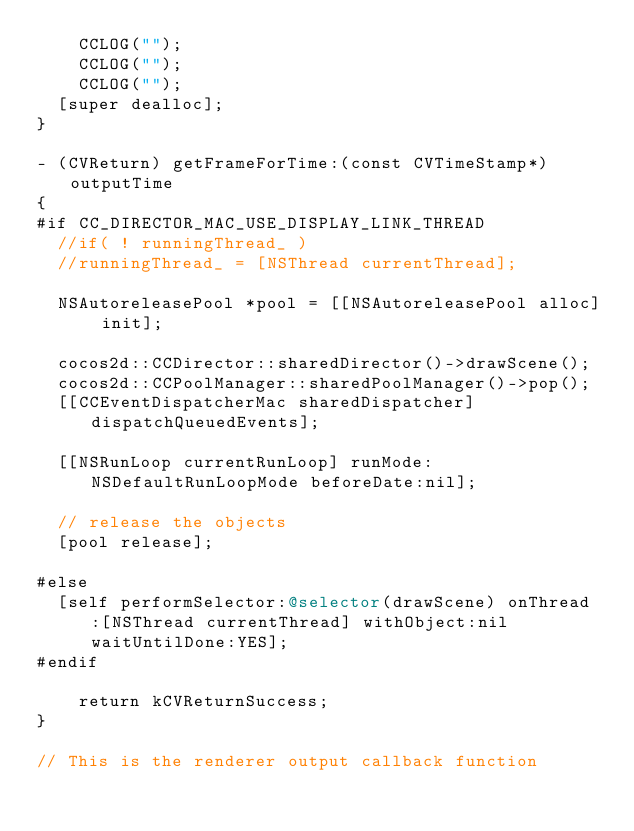<code> <loc_0><loc_0><loc_500><loc_500><_ObjectiveC_>    CCLOG("");
    CCLOG("");
    CCLOG("");
	[super dealloc];
}

- (CVReturn) getFrameForTime:(const CVTimeStamp*)outputTime
{
#if CC_DIRECTOR_MAC_USE_DISPLAY_LINK_THREAD
	//if( ! runningThread_ )
	//runningThread_ = [NSThread currentThread];
    
	NSAutoreleasePool *pool = [[NSAutoreleasePool alloc] init];
	
	cocos2d::CCDirector::sharedDirector()->drawScene();
	cocos2d::CCPoolManager::sharedPoolManager()->pop();
	[[CCEventDispatcherMac sharedDispatcher] dispatchQueuedEvents];
	
	[[NSRunLoop currentRunLoop] runMode:NSDefaultRunLoopMode beforeDate:nil];
	
	// release the objects
	[pool release];
	
#else
	[self performSelector:@selector(drawScene) onThread:[NSThread currentThread] withObject:nil waitUntilDone:YES];
#endif
	
    return kCVReturnSuccess;
}

// This is the renderer output callback function</code> 